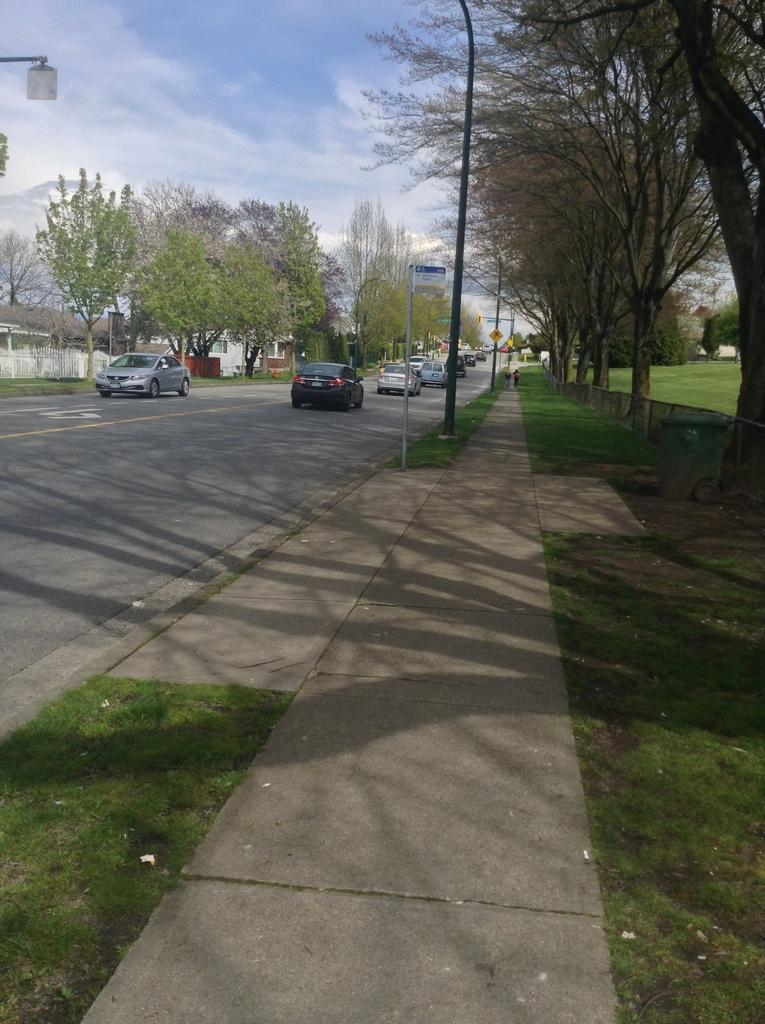What can be seen on the road in the image? There are vehicles on the road in the image. What type of natural elements are present in the image? There are trees and grass in the image. What structures can be seen in the image? There are poles in the image. What additional information is provided on a board in the image? There is a board with text in the image. What is visible in the background of the image? The sky is visible in the image. Can you tell me how many baseballs are lying on the grass in the image? There are no baseballs present in the image; it features vehicles on the road, trees, poles, a board with text, and grass. What is the son doing in the image? There is no son present in the image. 